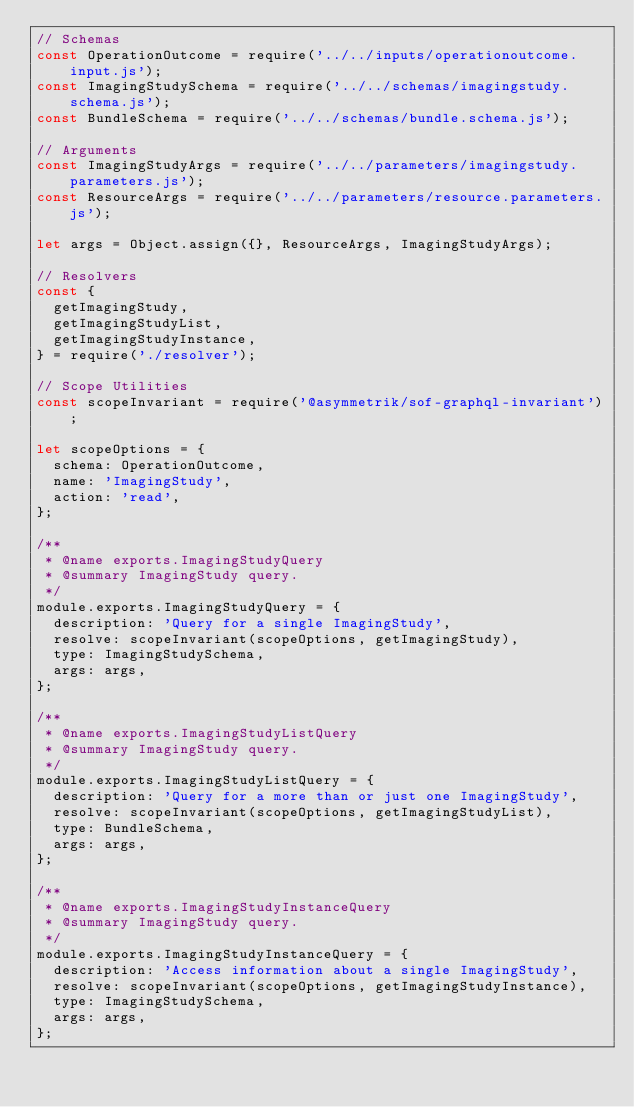<code> <loc_0><loc_0><loc_500><loc_500><_JavaScript_>// Schemas
const OperationOutcome = require('../../inputs/operationoutcome.input.js');
const ImagingStudySchema = require('../../schemas/imagingstudy.schema.js');
const BundleSchema = require('../../schemas/bundle.schema.js');

// Arguments
const ImagingStudyArgs = require('../../parameters/imagingstudy.parameters.js');
const ResourceArgs = require('../../parameters/resource.parameters.js');

let args = Object.assign({}, ResourceArgs, ImagingStudyArgs);

// Resolvers
const {
	getImagingStudy,
	getImagingStudyList,
	getImagingStudyInstance,
} = require('./resolver');

// Scope Utilities
const scopeInvariant = require('@asymmetrik/sof-graphql-invariant');

let scopeOptions = {
	schema: OperationOutcome,
	name: 'ImagingStudy',
	action: 'read',
};

/**
 * @name exports.ImagingStudyQuery
 * @summary ImagingStudy query.
 */
module.exports.ImagingStudyQuery = {
	description: 'Query for a single ImagingStudy',
	resolve: scopeInvariant(scopeOptions, getImagingStudy),
	type: ImagingStudySchema,
	args: args,
};

/**
 * @name exports.ImagingStudyListQuery
 * @summary ImagingStudy query.
 */
module.exports.ImagingStudyListQuery = {
	description: 'Query for a more than or just one ImagingStudy',
	resolve: scopeInvariant(scopeOptions, getImagingStudyList),
	type: BundleSchema,
	args: args,
};

/**
 * @name exports.ImagingStudyInstanceQuery
 * @summary ImagingStudy query.
 */
module.exports.ImagingStudyInstanceQuery = {
	description: 'Access information about a single ImagingStudy',
	resolve: scopeInvariant(scopeOptions, getImagingStudyInstance),
	type: ImagingStudySchema,
	args: args,
};
</code> 